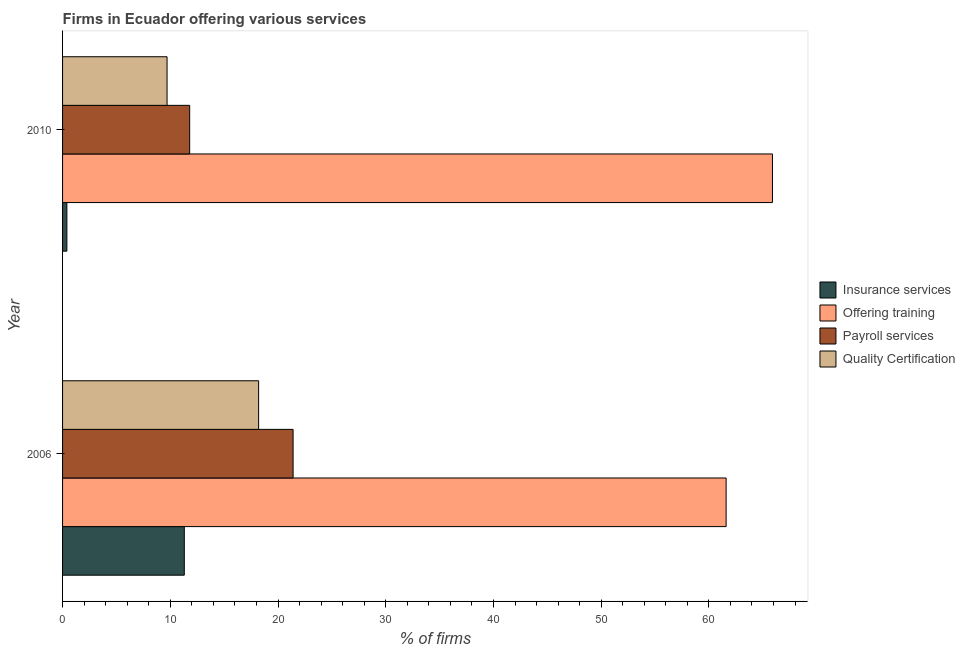How many groups of bars are there?
Make the answer very short. 2. Are the number of bars per tick equal to the number of legend labels?
Offer a very short reply. Yes. Are the number of bars on each tick of the Y-axis equal?
Provide a short and direct response. Yes. How many bars are there on the 2nd tick from the top?
Provide a short and direct response. 4. What is the label of the 2nd group of bars from the top?
Make the answer very short. 2006. In which year was the percentage of firms offering quality certification maximum?
Offer a terse response. 2006. What is the total percentage of firms offering insurance services in the graph?
Provide a short and direct response. 11.7. What is the difference between the percentage of firms offering payroll services in 2010 and the percentage of firms offering insurance services in 2006?
Make the answer very short. 0.5. What is the average percentage of firms offering payroll services per year?
Offer a terse response. 16.6. In the year 2010, what is the difference between the percentage of firms offering training and percentage of firms offering insurance services?
Make the answer very short. 65.5. What is the ratio of the percentage of firms offering quality certification in 2006 to that in 2010?
Your response must be concise. 1.88. Is the percentage of firms offering quality certification in 2006 less than that in 2010?
Your answer should be very brief. No. Is the difference between the percentage of firms offering quality certification in 2006 and 2010 greater than the difference between the percentage of firms offering payroll services in 2006 and 2010?
Offer a terse response. No. What does the 3rd bar from the top in 2010 represents?
Offer a terse response. Offering training. What does the 2nd bar from the bottom in 2006 represents?
Ensure brevity in your answer.  Offering training. Is it the case that in every year, the sum of the percentage of firms offering insurance services and percentage of firms offering training is greater than the percentage of firms offering payroll services?
Offer a terse response. Yes. Are all the bars in the graph horizontal?
Provide a short and direct response. Yes. How many years are there in the graph?
Ensure brevity in your answer.  2. What is the difference between two consecutive major ticks on the X-axis?
Your answer should be compact. 10. Are the values on the major ticks of X-axis written in scientific E-notation?
Provide a succinct answer. No. Does the graph contain any zero values?
Offer a terse response. No. What is the title of the graph?
Give a very brief answer. Firms in Ecuador offering various services . What is the label or title of the X-axis?
Ensure brevity in your answer.  % of firms. What is the label or title of the Y-axis?
Make the answer very short. Year. What is the % of firms in Offering training in 2006?
Provide a succinct answer. 61.6. What is the % of firms of Payroll services in 2006?
Your answer should be very brief. 21.4. What is the % of firms in Quality Certification in 2006?
Give a very brief answer. 18.2. What is the % of firms of Offering training in 2010?
Offer a very short reply. 65.9. Across all years, what is the maximum % of firms of Offering training?
Keep it short and to the point. 65.9. Across all years, what is the maximum % of firms of Payroll services?
Provide a succinct answer. 21.4. Across all years, what is the minimum % of firms in Offering training?
Provide a succinct answer. 61.6. Across all years, what is the minimum % of firms in Payroll services?
Provide a succinct answer. 11.8. What is the total % of firms in Insurance services in the graph?
Make the answer very short. 11.7. What is the total % of firms of Offering training in the graph?
Your answer should be very brief. 127.5. What is the total % of firms in Payroll services in the graph?
Give a very brief answer. 33.2. What is the total % of firms in Quality Certification in the graph?
Give a very brief answer. 27.9. What is the difference between the % of firms in Insurance services in 2006 and that in 2010?
Your answer should be very brief. 10.9. What is the difference between the % of firms in Offering training in 2006 and that in 2010?
Ensure brevity in your answer.  -4.3. What is the difference between the % of firms in Payroll services in 2006 and that in 2010?
Ensure brevity in your answer.  9.6. What is the difference between the % of firms of Quality Certification in 2006 and that in 2010?
Offer a terse response. 8.5. What is the difference between the % of firms of Insurance services in 2006 and the % of firms of Offering training in 2010?
Offer a terse response. -54.6. What is the difference between the % of firms of Insurance services in 2006 and the % of firms of Payroll services in 2010?
Provide a short and direct response. -0.5. What is the difference between the % of firms of Insurance services in 2006 and the % of firms of Quality Certification in 2010?
Your answer should be compact. 1.6. What is the difference between the % of firms of Offering training in 2006 and the % of firms of Payroll services in 2010?
Make the answer very short. 49.8. What is the difference between the % of firms of Offering training in 2006 and the % of firms of Quality Certification in 2010?
Provide a succinct answer. 51.9. What is the average % of firms of Insurance services per year?
Keep it short and to the point. 5.85. What is the average % of firms of Offering training per year?
Ensure brevity in your answer.  63.75. What is the average % of firms of Quality Certification per year?
Offer a very short reply. 13.95. In the year 2006, what is the difference between the % of firms in Insurance services and % of firms in Offering training?
Keep it short and to the point. -50.3. In the year 2006, what is the difference between the % of firms of Insurance services and % of firms of Payroll services?
Keep it short and to the point. -10.1. In the year 2006, what is the difference between the % of firms of Insurance services and % of firms of Quality Certification?
Provide a succinct answer. -6.9. In the year 2006, what is the difference between the % of firms of Offering training and % of firms of Payroll services?
Your response must be concise. 40.2. In the year 2006, what is the difference between the % of firms of Offering training and % of firms of Quality Certification?
Keep it short and to the point. 43.4. In the year 2010, what is the difference between the % of firms in Insurance services and % of firms in Offering training?
Ensure brevity in your answer.  -65.5. In the year 2010, what is the difference between the % of firms of Insurance services and % of firms of Quality Certification?
Make the answer very short. -9.3. In the year 2010, what is the difference between the % of firms in Offering training and % of firms in Payroll services?
Your answer should be very brief. 54.1. In the year 2010, what is the difference between the % of firms in Offering training and % of firms in Quality Certification?
Your answer should be very brief. 56.2. In the year 2010, what is the difference between the % of firms of Payroll services and % of firms of Quality Certification?
Keep it short and to the point. 2.1. What is the ratio of the % of firms of Insurance services in 2006 to that in 2010?
Your answer should be very brief. 28.25. What is the ratio of the % of firms of Offering training in 2006 to that in 2010?
Your response must be concise. 0.93. What is the ratio of the % of firms of Payroll services in 2006 to that in 2010?
Offer a terse response. 1.81. What is the ratio of the % of firms of Quality Certification in 2006 to that in 2010?
Offer a very short reply. 1.88. What is the difference between the highest and the lowest % of firms in Insurance services?
Your response must be concise. 10.9. What is the difference between the highest and the lowest % of firms of Offering training?
Your answer should be very brief. 4.3. 